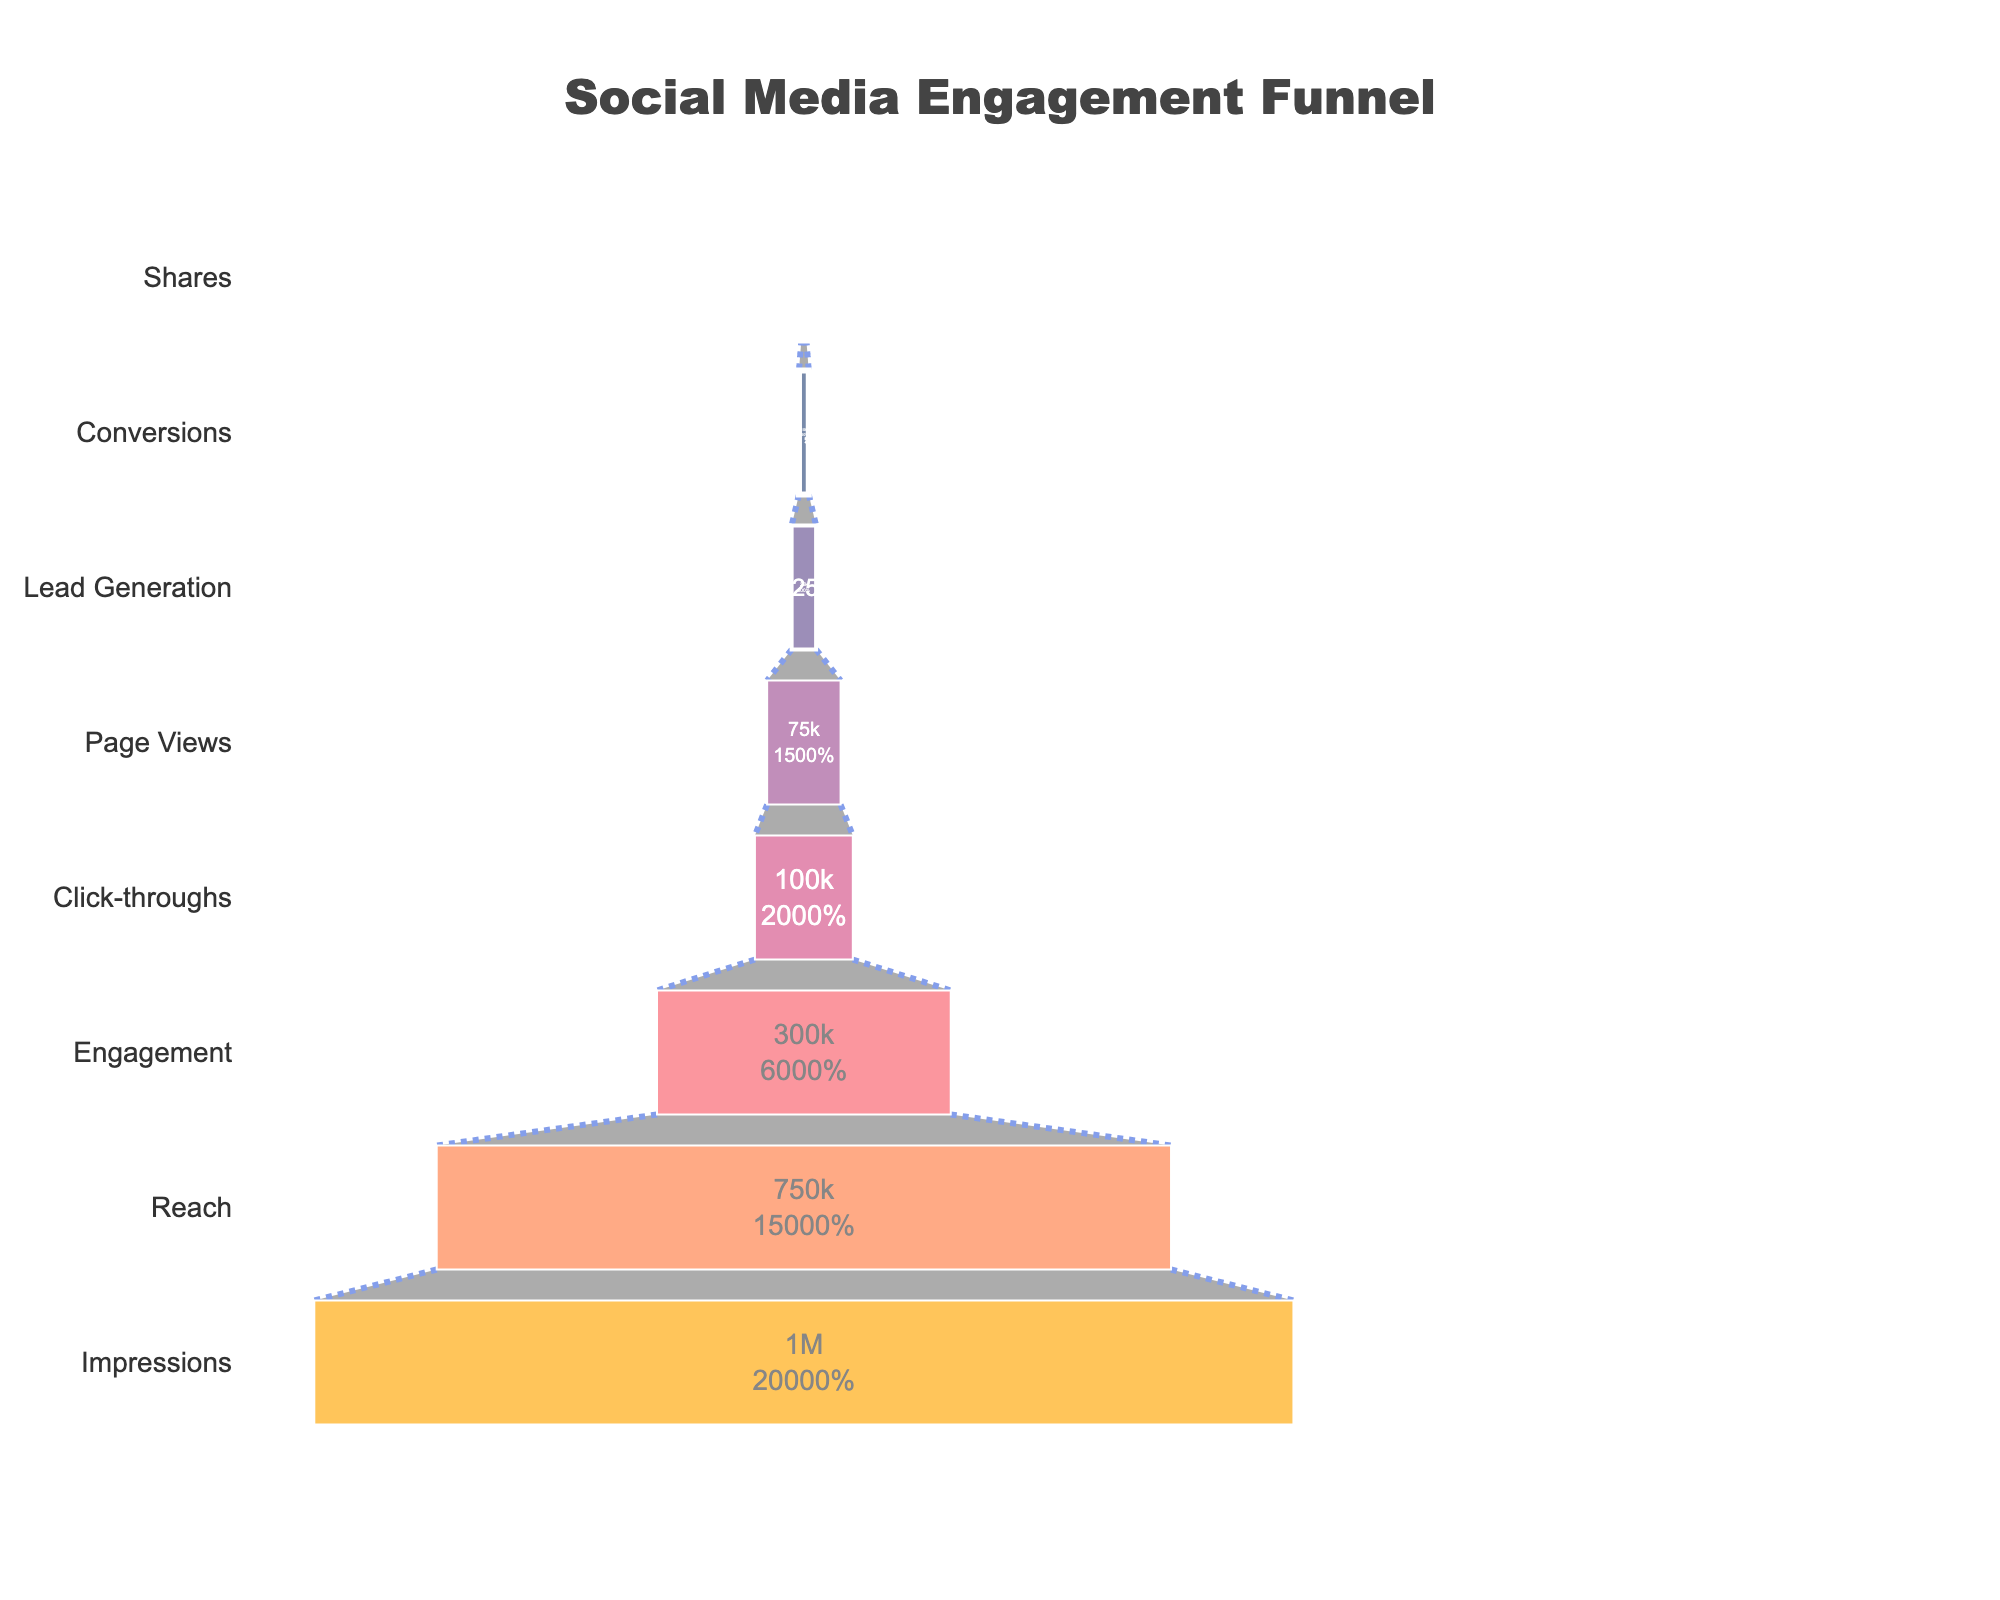How many stages are there in the funnel? To find the number of stages, simply count the different stages listed in the funnel chart.
Answer: 8 What stage has the largest number of users? By looking at the funnel chart, identify the stage with the highest value. The stage with 1,000,000 users is the largest.
Answer: Impressions How many users reach the Engagement stage? Look at the value associated with the Engagement stage in the chart.
Answer: 300,000 What is the percentage drop from Impressions to Reach? The percentage drop from Impressions to Reach is calculated by \((1 - \frac{\text{Reach}}{\text{Impressions}}) \times 100\). Plugging in the values: \((1 - \frac{750,000}{1,000,000}) \times 100 = 25\%\).
Answer: 25% What is the difference in the number of users between Click-throughs and Conversions? Subtract the number of users in the Conversions stage from the Click-throughs stage: \(100,000 - 10,000\).
Answer: 90,000 Which stages have fewer than 100,000 users? Identify the stages with user counts less than 100,000: Click-throughs (100,000), Page Views (75,000), Lead Generation (25,000), Conversions (10,000), and Shares (5,000).
Answer: Page Views, Lead Generation, Conversions, Shares What is the conversion rate from Page Views to Conversions? The conversion rate is calculated by \(\frac{\text{Conversions}}{\text{Page Views}} \times 100\). Plugging in the values: \(\frac{10,000}{75,000} \times 100 \approx 13.33\%\).
Answer: 13.33% What is the total number of users from Engagement to Shares? Sum the number of users at each of these stages: \(300,000 + 100,000 + 75,000 + 25,000 + 10,000 + 5,000 = 515,000\).
Answer: 515,000 Between which two stages is the largest drop in user numbers? Calculate the differences in user numbers between each consecutive stage and identify the largest drop. The drop from Engagement (300,000) to Click-throughs (100,000) is the largest at \(200,000\).
Answer: Engagement to Click-throughs 